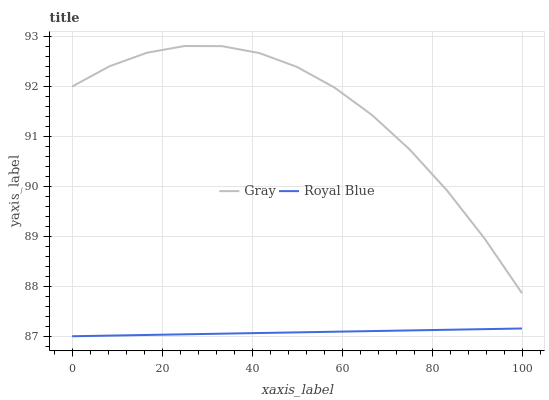Does Royal Blue have the minimum area under the curve?
Answer yes or no. Yes. Does Gray have the maximum area under the curve?
Answer yes or no. Yes. Does Royal Blue have the maximum area under the curve?
Answer yes or no. No. Is Royal Blue the smoothest?
Answer yes or no. Yes. Is Gray the roughest?
Answer yes or no. Yes. Is Royal Blue the roughest?
Answer yes or no. No. Does Royal Blue have the lowest value?
Answer yes or no. Yes. Does Gray have the highest value?
Answer yes or no. Yes. Does Royal Blue have the highest value?
Answer yes or no. No. Is Royal Blue less than Gray?
Answer yes or no. Yes. Is Gray greater than Royal Blue?
Answer yes or no. Yes. Does Royal Blue intersect Gray?
Answer yes or no. No. 